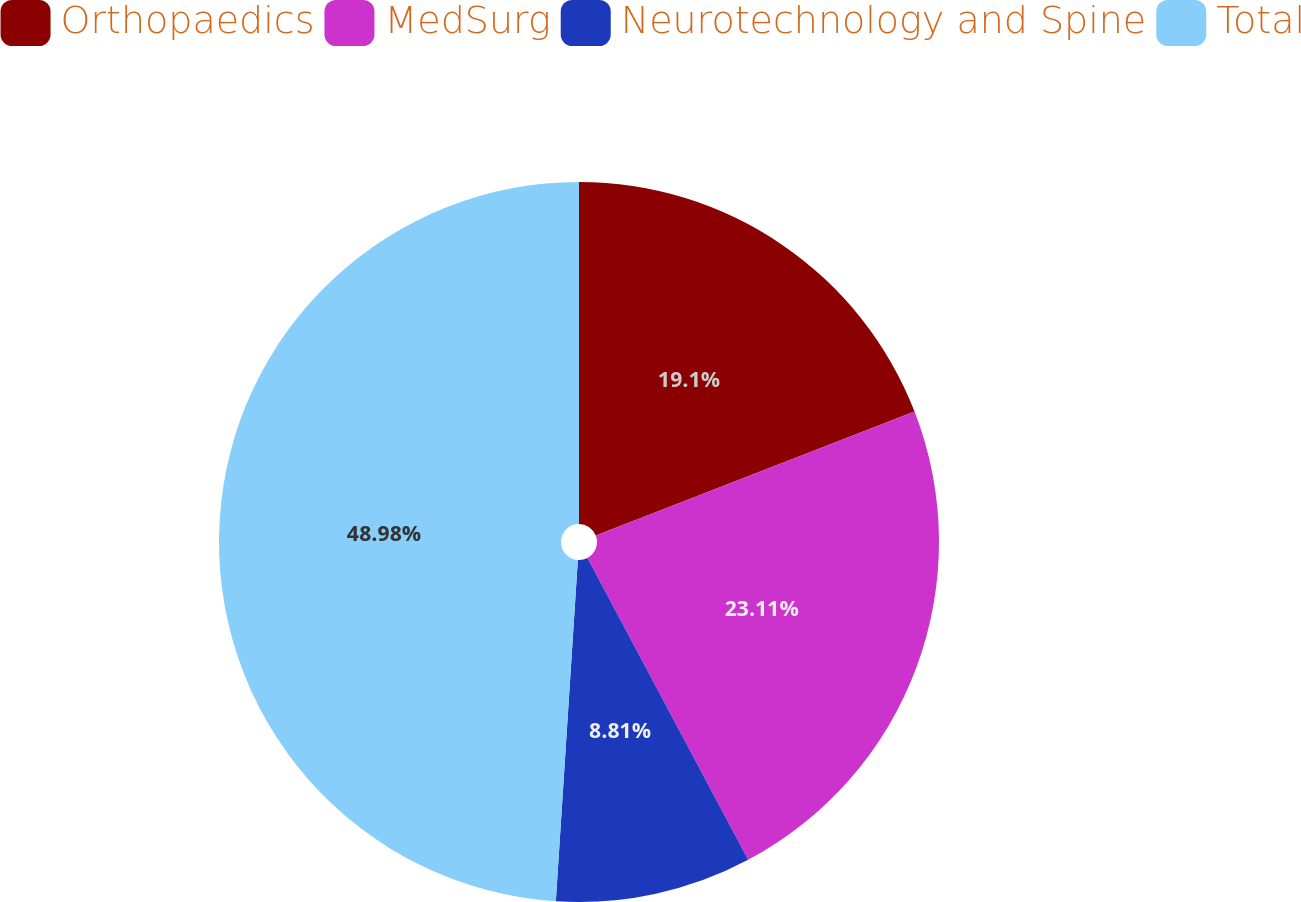<chart> <loc_0><loc_0><loc_500><loc_500><pie_chart><fcel>Orthopaedics<fcel>MedSurg<fcel>Neurotechnology and Spine<fcel>Total<nl><fcel>19.1%<fcel>23.11%<fcel>8.81%<fcel>48.97%<nl></chart> 